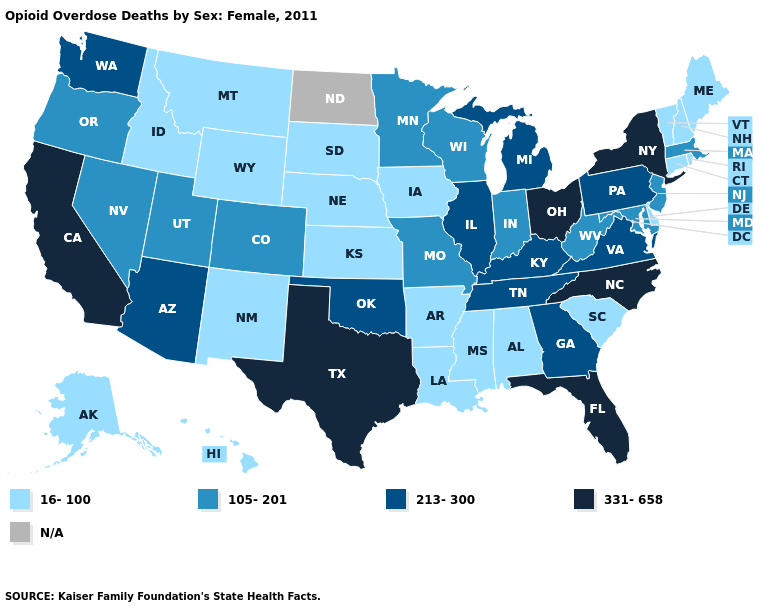Name the states that have a value in the range 105-201?
Short answer required. Colorado, Indiana, Maryland, Massachusetts, Minnesota, Missouri, Nevada, New Jersey, Oregon, Utah, West Virginia, Wisconsin. What is the value of Michigan?
Short answer required. 213-300. What is the value of Rhode Island?
Give a very brief answer. 16-100. What is the value of Wyoming?
Give a very brief answer. 16-100. Name the states that have a value in the range 105-201?
Short answer required. Colorado, Indiana, Maryland, Massachusetts, Minnesota, Missouri, Nevada, New Jersey, Oregon, Utah, West Virginia, Wisconsin. Which states have the lowest value in the USA?
Concise answer only. Alabama, Alaska, Arkansas, Connecticut, Delaware, Hawaii, Idaho, Iowa, Kansas, Louisiana, Maine, Mississippi, Montana, Nebraska, New Hampshire, New Mexico, Rhode Island, South Carolina, South Dakota, Vermont, Wyoming. What is the lowest value in the MidWest?
Short answer required. 16-100. Does the first symbol in the legend represent the smallest category?
Write a very short answer. Yes. What is the value of Indiana?
Quick response, please. 105-201. Does New York have the highest value in the Northeast?
Concise answer only. Yes. Name the states that have a value in the range 105-201?
Short answer required. Colorado, Indiana, Maryland, Massachusetts, Minnesota, Missouri, Nevada, New Jersey, Oregon, Utah, West Virginia, Wisconsin. What is the value of South Carolina?
Write a very short answer. 16-100. What is the value of Delaware?
Concise answer only. 16-100. What is the value of Wyoming?
Quick response, please. 16-100. What is the value of Colorado?
Short answer required. 105-201. 